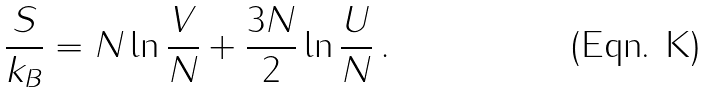Convert formula to latex. <formula><loc_0><loc_0><loc_500><loc_500>\frac { S } { k _ { B } } = N \ln \frac { V } { N } + \frac { 3 N } { 2 } \ln \frac { U } { N } \, .</formula> 